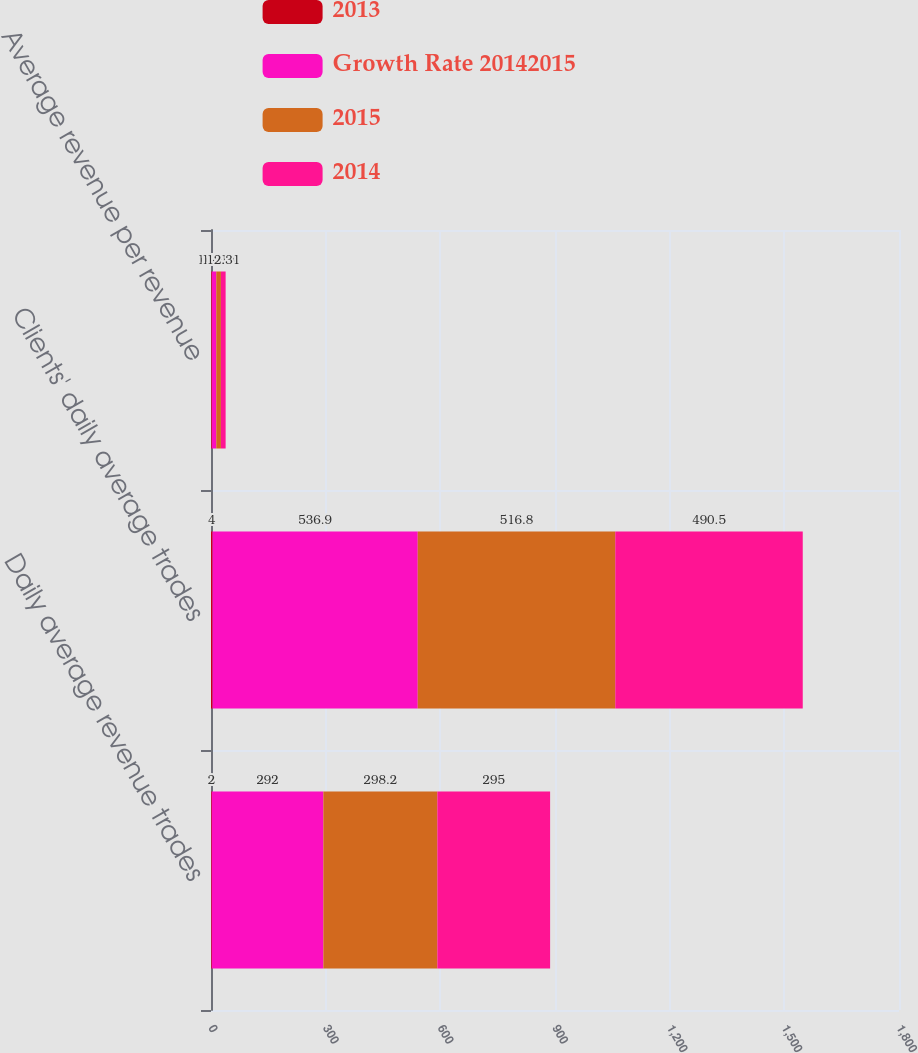Convert chart to OTSL. <chart><loc_0><loc_0><loc_500><loc_500><stacked_bar_chart><ecel><fcel>Daily average revenue trades<fcel>Clients' daily average trades<fcel>Average revenue per revenue<nl><fcel>2013<fcel>2<fcel>4<fcel>2<nl><fcel>Growth Rate 20142015<fcel>292<fcel>536.9<fcel>11.83<nl><fcel>2015<fcel>298.2<fcel>516.8<fcel>12.13<nl><fcel>2014<fcel>295<fcel>490.5<fcel>12.31<nl></chart> 